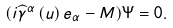Convert formula to latex. <formula><loc_0><loc_0><loc_500><loc_500>( i \widehat { \gamma } ^ { \alpha } \left ( u \right ) e _ { \alpha } - M ) \Psi = 0 .</formula> 